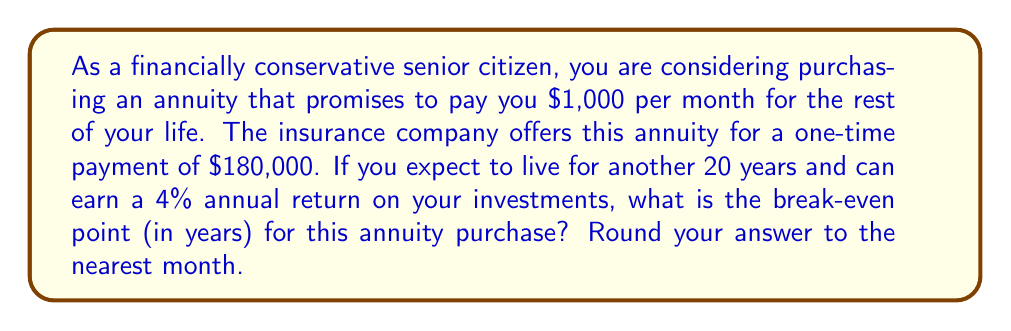Teach me how to tackle this problem. To calculate the break-even point, we need to determine how long it will take for the present value of the annuity payments to equal the initial investment.

1. Calculate the present value of the annuity:
   Let's use the present value of an annuity formula:
   $$ PV = PMT \times \frac{1 - (1 + r)^{-n}}{r} $$
   Where:
   $PV$ = Present Value (initial investment)
   $PMT$ = Monthly Payment
   $r$ = Monthly interest rate
   $n$ = Number of months

2. We know:
   $PV = \$180,000$
   $PMT = \$1,000$
   Annual interest rate = 4% = 0.04
   Monthly interest rate, $r = \frac{0.04}{12} = 0.0033333$

3. Substitute these values into the equation:
   $$ 180,000 = 1,000 \times \frac{1 - (1 + 0.0033333)^{-n}}{0.0033333} $$

4. Solve for $n$:
   $$ 180,000 \times 0.0033333 = 1,000 \times (1 - (1 + 0.0033333)^{-n}) $$
   $$ 0.6 = 1 - (1 + 0.0033333)^{-n} $$
   $$ 0.4 = (1 + 0.0033333)^{-n} $$
   $$ \ln(0.4) = -n \times \ln(1.0033333) $$
   $$ n = \frac{-\ln(0.4)}{\ln(1.0033333)} \approx 277.8 $$

5. Convert months to years:
   $$ \text{Years} = \frac{277.8}{12} \approx 23.15 \text{ years} $$

Rounding to the nearest month, we get 23 years and 2 months.
Answer: The break-even point for purchasing the annuity is approximately 23 years and 2 months. 